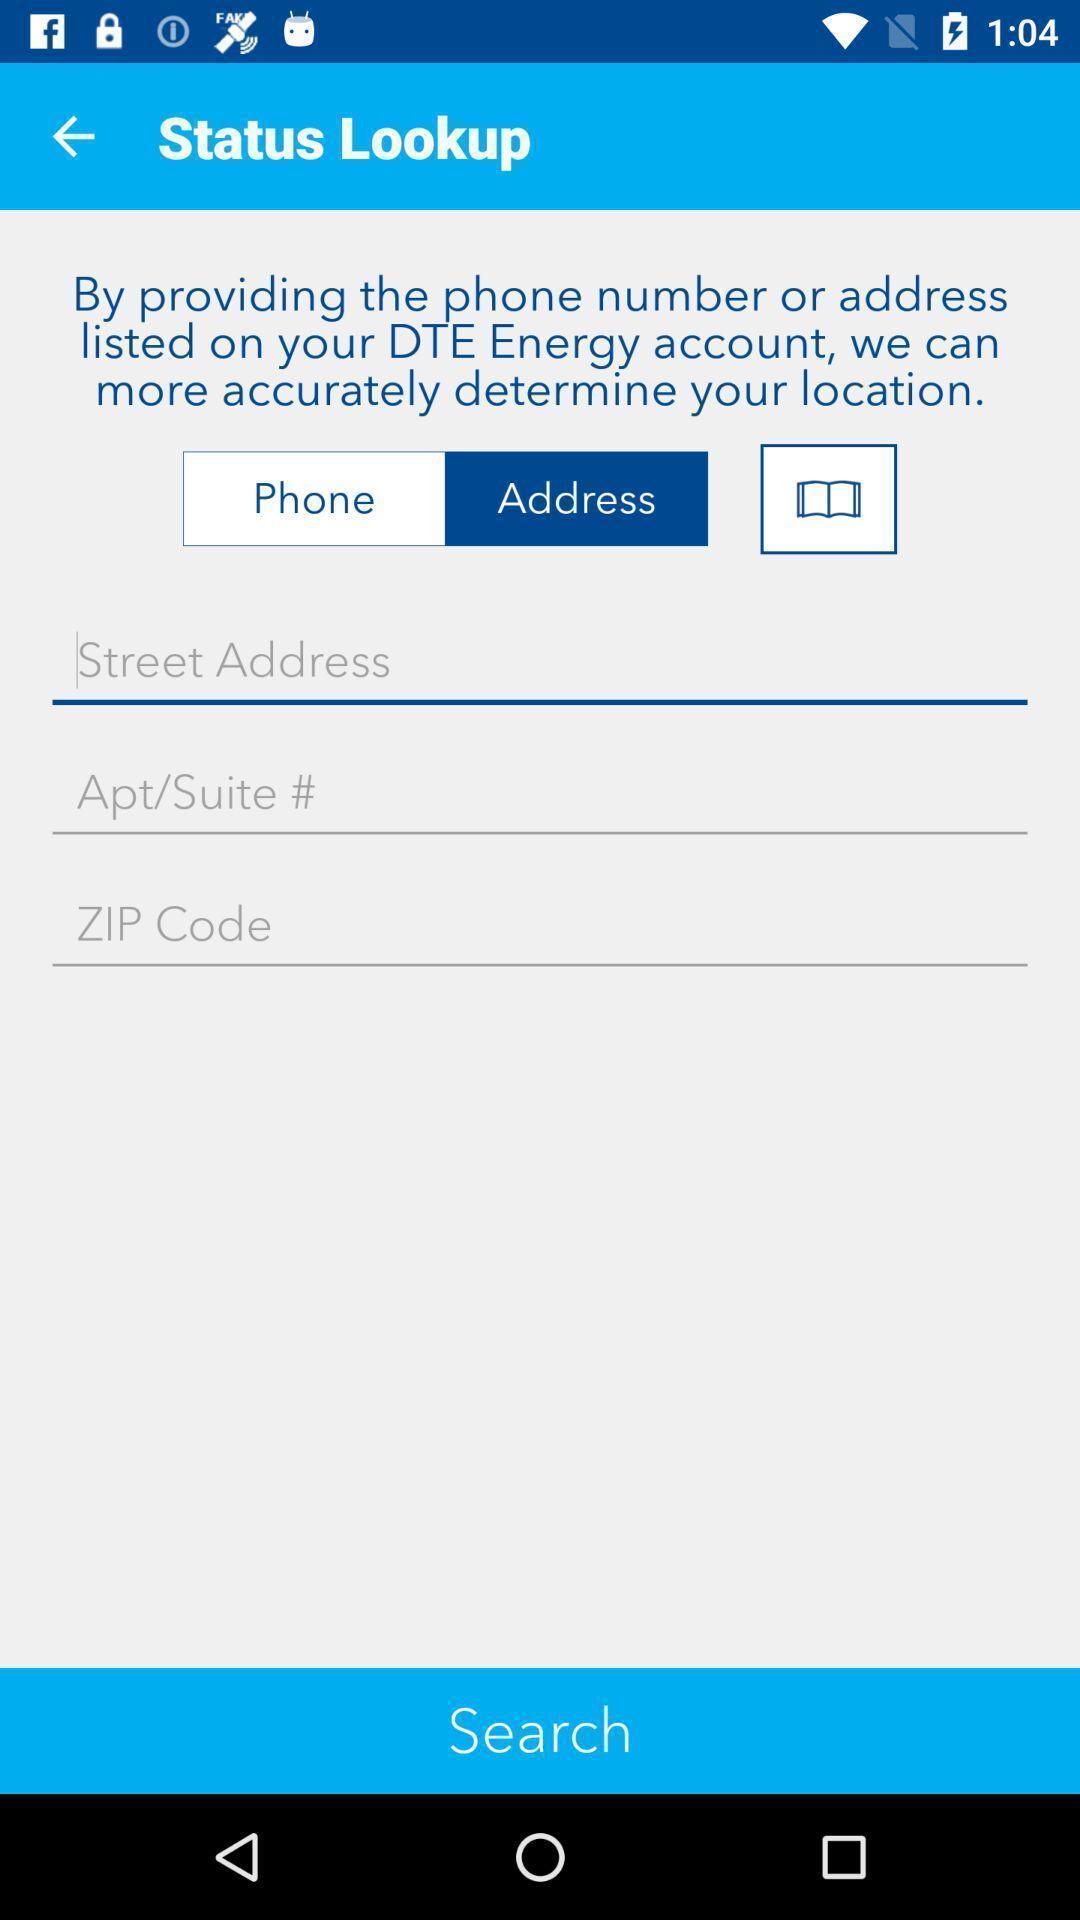Summarize the main components in this picture. Page showing information about status lookup. 